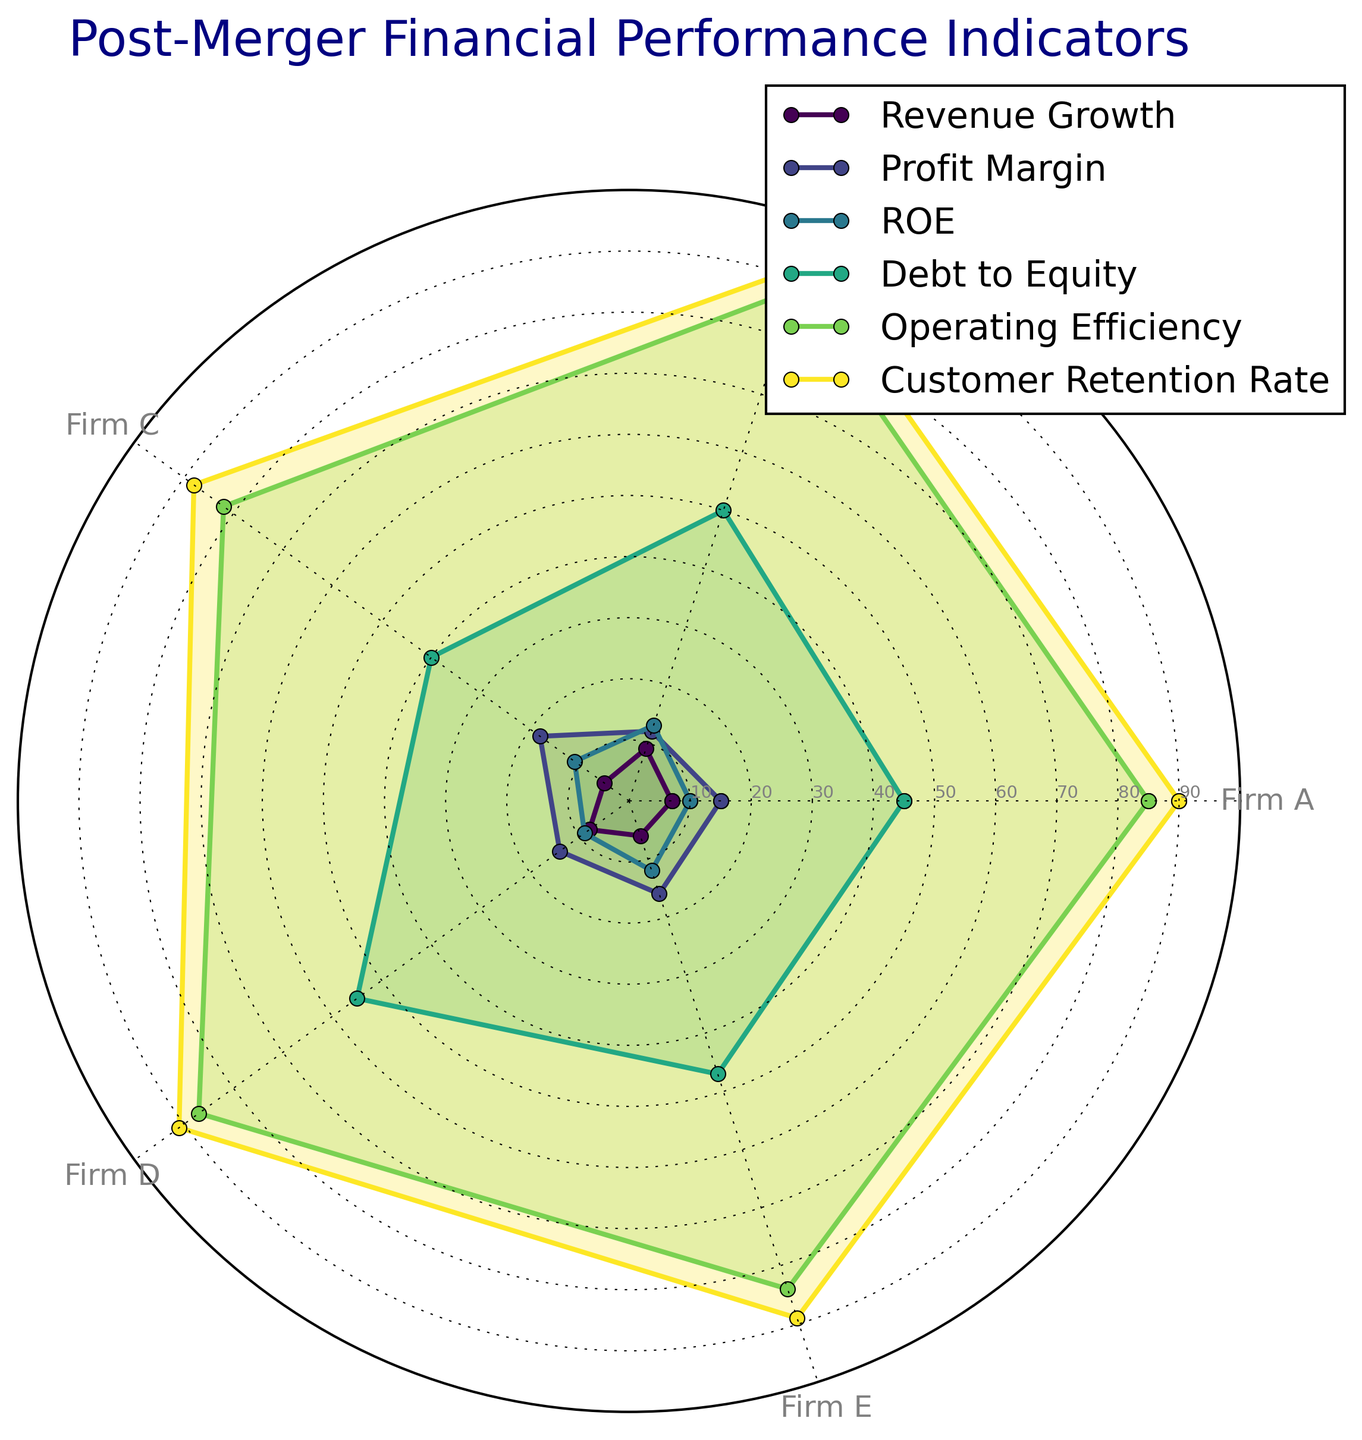Which firm has the highest profit margin? Observe the Profit Margin axis on the radar chart. Firm C extends the furthest along this axis, indicating that Firm C has the highest profit margin.
Answer: Firm C Compare the revenue growth between Firm A and Firm D. Which firm has a higher revenue growth? By checking the Revenue Growth axis, Firm D's line is further out than Firm A's, meaning Firm D has a higher revenue growth.
Answer: Firm D Which firm has the lowest customer retention rate? On the Customer Retention Rate axis, Firm C's line is closer to the center compared to the other firms, indicating the lowest customer retention rate.
Answer: Firm C Calculate the average operating efficiency of Firm A and Firm B. Sum the Operating Efficiency values for Firm A and Firm B (85 + 88) and divide by 2 to get the average: (85 + 88) / 2 = 86.5.
Answer: 86.5 Which firm has the highest debt to equity ratio, and what is this ratio? The Debt to Equity axis shows Firm D’s line extends the furthest, marking it having the highest value. The ratio for Firm D is 55.
Answer: Firm D, 55 Assess the relative performance of Firm B and Firm E in terms of ROE. Who performs better? Examine the ROE axis. Firm B’s value of 13 is higher than Firm E’s value of 12, indicating Firm B performs better in terms of ROE.
Answer: Firm B Which firm shows a better balance between revenue growth and profit margin? Look at the Revenue Growth and Profit Margin axes. Firm C shows high values on Profit Margin (18) and moderate values on Revenue Growth (5), indicating a balanced performance.
Answer: Firm C Identify the firm with the lowest operating efficiency and debt to equity ratio. Check the Operating Efficiency and Debt to Equity axes. Firm C has the lowest operating efficiency (82). Firm C also has the lowest debt to equity ratio (40) among the firms.
Answer: Firm C How does Firm E’s customer retention rate compare to the other firms? Firm E’s line on the Customer Retention Rate axis is close to the outer edge (89), similar to other firms but not the highest (Firm B has 92).
Answer: Comparable but not the highest 